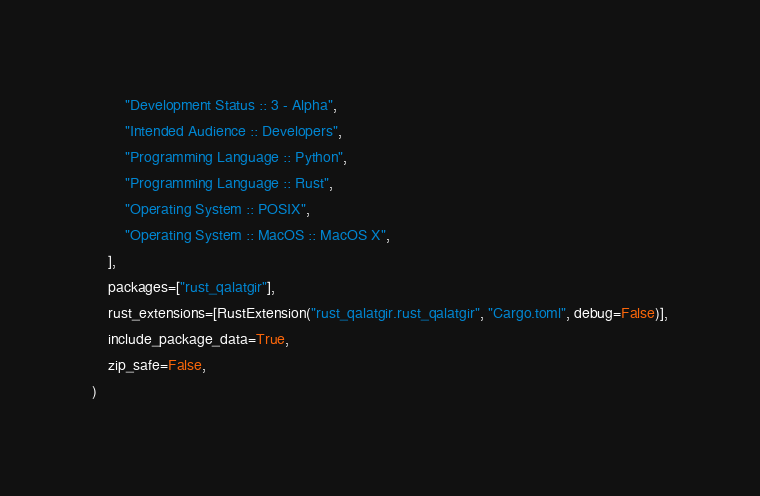<code> <loc_0><loc_0><loc_500><loc_500><_Python_>        "Development Status :: 3 - Alpha",
        "Intended Audience :: Developers",
        "Programming Language :: Python",
        "Programming Language :: Rust",
        "Operating System :: POSIX",
        "Operating System :: MacOS :: MacOS X",
    ],
    packages=["rust_qalatgir"],
    rust_extensions=[RustExtension("rust_qalatgir.rust_qalatgir", "Cargo.toml", debug=False)],
    include_package_data=True,
    zip_safe=False,
)</code> 